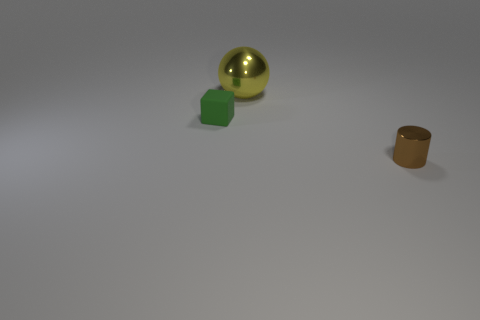Add 1 tiny green objects. How many objects exist? 4 Subtract all cubes. How many objects are left? 2 Subtract all small cyan rubber cylinders. Subtract all small brown objects. How many objects are left? 2 Add 3 large things. How many large things are left? 4 Add 3 green things. How many green things exist? 4 Subtract 0 green cylinders. How many objects are left? 3 Subtract all brown blocks. Subtract all yellow cylinders. How many blocks are left? 1 